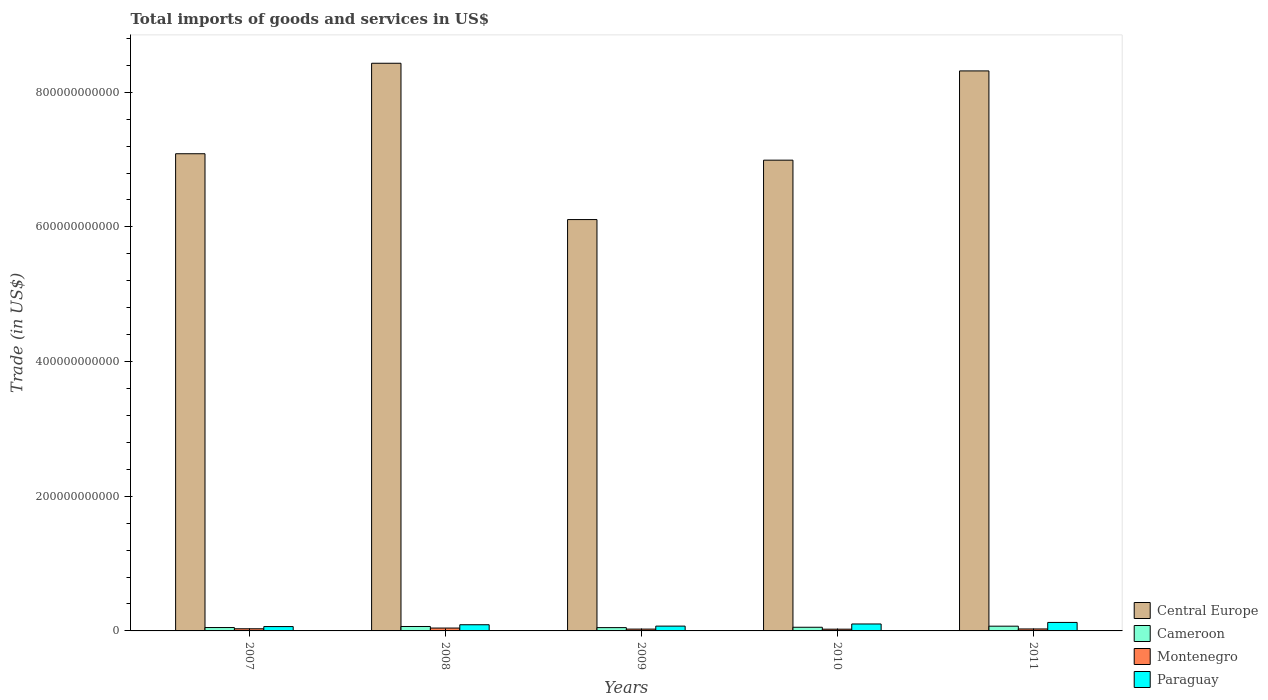How many different coloured bars are there?
Keep it short and to the point. 4. Are the number of bars on each tick of the X-axis equal?
Offer a terse response. Yes. How many bars are there on the 2nd tick from the left?
Give a very brief answer. 4. How many bars are there on the 2nd tick from the right?
Provide a short and direct response. 4. What is the label of the 5th group of bars from the left?
Keep it short and to the point. 2011. In how many cases, is the number of bars for a given year not equal to the number of legend labels?
Offer a terse response. 0. What is the total imports of goods and services in Central Europe in 2010?
Give a very brief answer. 6.99e+11. Across all years, what is the maximum total imports of goods and services in Central Europe?
Give a very brief answer. 8.43e+11. Across all years, what is the minimum total imports of goods and services in Cameroon?
Ensure brevity in your answer.  4.92e+09. What is the total total imports of goods and services in Cameroon in the graph?
Your response must be concise. 2.90e+1. What is the difference between the total imports of goods and services in Paraguay in 2007 and that in 2010?
Your answer should be compact. -3.85e+09. What is the difference between the total imports of goods and services in Cameroon in 2011 and the total imports of goods and services in Montenegro in 2008?
Provide a short and direct response. 2.79e+09. What is the average total imports of goods and services in Paraguay per year?
Offer a terse response. 9.14e+09. In the year 2008, what is the difference between the total imports of goods and services in Cameroon and total imports of goods and services in Central Europe?
Ensure brevity in your answer.  -8.36e+11. In how many years, is the total imports of goods and services in Montenegro greater than 840000000000 US$?
Make the answer very short. 0. What is the ratio of the total imports of goods and services in Paraguay in 2007 to that in 2009?
Your answer should be compact. 0.91. Is the difference between the total imports of goods and services in Cameroon in 2008 and 2009 greater than the difference between the total imports of goods and services in Central Europe in 2008 and 2009?
Keep it short and to the point. No. What is the difference between the highest and the second highest total imports of goods and services in Cameroon?
Provide a short and direct response. 4.59e+08. What is the difference between the highest and the lowest total imports of goods and services in Cameroon?
Offer a very short reply. 2.12e+09. What does the 2nd bar from the left in 2009 represents?
Provide a succinct answer. Cameroon. What does the 3rd bar from the right in 2007 represents?
Offer a very short reply. Cameroon. Are all the bars in the graph horizontal?
Your response must be concise. No. What is the difference between two consecutive major ticks on the Y-axis?
Offer a terse response. 2.00e+11. Does the graph contain grids?
Provide a succinct answer. No. Where does the legend appear in the graph?
Offer a very short reply. Bottom right. What is the title of the graph?
Provide a succinct answer. Total imports of goods and services in US$. Does "Samoa" appear as one of the legend labels in the graph?
Your answer should be compact. No. What is the label or title of the X-axis?
Give a very brief answer. Years. What is the label or title of the Y-axis?
Give a very brief answer. Trade (in US$). What is the Trade (in US$) of Central Europe in 2007?
Your response must be concise. 7.09e+11. What is the Trade (in US$) of Cameroon in 2007?
Offer a terse response. 5.03e+09. What is the Trade (in US$) of Montenegro in 2007?
Ensure brevity in your answer.  3.18e+09. What is the Trade (in US$) of Paraguay in 2007?
Ensure brevity in your answer.  6.46e+09. What is the Trade (in US$) of Central Europe in 2008?
Provide a succinct answer. 8.43e+11. What is the Trade (in US$) in Cameroon in 2008?
Your response must be concise. 6.58e+09. What is the Trade (in US$) in Montenegro in 2008?
Your answer should be very brief. 4.25e+09. What is the Trade (in US$) in Paraguay in 2008?
Make the answer very short. 9.17e+09. What is the Trade (in US$) in Central Europe in 2009?
Make the answer very short. 6.11e+11. What is the Trade (in US$) of Cameroon in 2009?
Offer a very short reply. 4.92e+09. What is the Trade (in US$) of Montenegro in 2009?
Offer a terse response. 2.71e+09. What is the Trade (in US$) of Paraguay in 2009?
Make the answer very short. 7.13e+09. What is the Trade (in US$) in Central Europe in 2010?
Keep it short and to the point. 6.99e+11. What is the Trade (in US$) in Cameroon in 2010?
Offer a terse response. 5.44e+09. What is the Trade (in US$) of Montenegro in 2010?
Provide a short and direct response. 2.60e+09. What is the Trade (in US$) of Paraguay in 2010?
Your response must be concise. 1.03e+1. What is the Trade (in US$) in Central Europe in 2011?
Your answer should be compact. 8.32e+11. What is the Trade (in US$) of Cameroon in 2011?
Offer a terse response. 7.04e+09. What is the Trade (in US$) in Montenegro in 2011?
Offer a very short reply. 2.92e+09. What is the Trade (in US$) in Paraguay in 2011?
Your answer should be compact. 1.26e+1. Across all years, what is the maximum Trade (in US$) of Central Europe?
Provide a succinct answer. 8.43e+11. Across all years, what is the maximum Trade (in US$) of Cameroon?
Offer a terse response. 7.04e+09. Across all years, what is the maximum Trade (in US$) in Montenegro?
Provide a short and direct response. 4.25e+09. Across all years, what is the maximum Trade (in US$) in Paraguay?
Your answer should be very brief. 1.26e+1. Across all years, what is the minimum Trade (in US$) in Central Europe?
Your answer should be very brief. 6.11e+11. Across all years, what is the minimum Trade (in US$) in Cameroon?
Give a very brief answer. 4.92e+09. Across all years, what is the minimum Trade (in US$) of Montenegro?
Your answer should be very brief. 2.60e+09. Across all years, what is the minimum Trade (in US$) in Paraguay?
Offer a terse response. 6.46e+09. What is the total Trade (in US$) in Central Europe in the graph?
Ensure brevity in your answer.  3.69e+12. What is the total Trade (in US$) in Cameroon in the graph?
Give a very brief answer. 2.90e+1. What is the total Trade (in US$) of Montenegro in the graph?
Your answer should be compact. 1.57e+1. What is the total Trade (in US$) of Paraguay in the graph?
Your response must be concise. 4.57e+1. What is the difference between the Trade (in US$) of Central Europe in 2007 and that in 2008?
Ensure brevity in your answer.  -1.34e+11. What is the difference between the Trade (in US$) in Cameroon in 2007 and that in 2008?
Give a very brief answer. -1.55e+09. What is the difference between the Trade (in US$) in Montenegro in 2007 and that in 2008?
Provide a succinct answer. -1.07e+09. What is the difference between the Trade (in US$) in Paraguay in 2007 and that in 2008?
Your response must be concise. -2.70e+09. What is the difference between the Trade (in US$) in Central Europe in 2007 and that in 2009?
Your answer should be very brief. 9.78e+1. What is the difference between the Trade (in US$) of Cameroon in 2007 and that in 2009?
Keep it short and to the point. 1.11e+08. What is the difference between the Trade (in US$) in Montenegro in 2007 and that in 2009?
Provide a short and direct response. 4.72e+08. What is the difference between the Trade (in US$) of Paraguay in 2007 and that in 2009?
Offer a terse response. -6.68e+08. What is the difference between the Trade (in US$) of Central Europe in 2007 and that in 2010?
Make the answer very short. 9.53e+09. What is the difference between the Trade (in US$) in Cameroon in 2007 and that in 2010?
Give a very brief answer. -4.09e+08. What is the difference between the Trade (in US$) in Montenegro in 2007 and that in 2010?
Offer a terse response. 5.84e+08. What is the difference between the Trade (in US$) of Paraguay in 2007 and that in 2010?
Your answer should be compact. -3.85e+09. What is the difference between the Trade (in US$) in Central Europe in 2007 and that in 2011?
Offer a terse response. -1.23e+11. What is the difference between the Trade (in US$) in Cameroon in 2007 and that in 2011?
Provide a short and direct response. -2.01e+09. What is the difference between the Trade (in US$) in Montenegro in 2007 and that in 2011?
Offer a very short reply. 2.62e+08. What is the difference between the Trade (in US$) of Paraguay in 2007 and that in 2011?
Offer a terse response. -6.15e+09. What is the difference between the Trade (in US$) of Central Europe in 2008 and that in 2009?
Give a very brief answer. 2.32e+11. What is the difference between the Trade (in US$) of Cameroon in 2008 and that in 2009?
Your answer should be very brief. 1.66e+09. What is the difference between the Trade (in US$) of Montenegro in 2008 and that in 2009?
Your answer should be very brief. 1.54e+09. What is the difference between the Trade (in US$) of Paraguay in 2008 and that in 2009?
Your response must be concise. 2.04e+09. What is the difference between the Trade (in US$) of Central Europe in 2008 and that in 2010?
Give a very brief answer. 1.44e+11. What is the difference between the Trade (in US$) in Cameroon in 2008 and that in 2010?
Your answer should be compact. 1.14e+09. What is the difference between the Trade (in US$) in Montenegro in 2008 and that in 2010?
Give a very brief answer. 1.65e+09. What is the difference between the Trade (in US$) in Paraguay in 2008 and that in 2010?
Your answer should be very brief. -1.15e+09. What is the difference between the Trade (in US$) of Central Europe in 2008 and that in 2011?
Give a very brief answer. 1.14e+1. What is the difference between the Trade (in US$) in Cameroon in 2008 and that in 2011?
Ensure brevity in your answer.  -4.59e+08. What is the difference between the Trade (in US$) of Montenegro in 2008 and that in 2011?
Your answer should be very brief. 1.33e+09. What is the difference between the Trade (in US$) in Paraguay in 2008 and that in 2011?
Offer a very short reply. -3.44e+09. What is the difference between the Trade (in US$) in Central Europe in 2009 and that in 2010?
Make the answer very short. -8.82e+1. What is the difference between the Trade (in US$) in Cameroon in 2009 and that in 2010?
Your answer should be very brief. -5.20e+08. What is the difference between the Trade (in US$) in Montenegro in 2009 and that in 2010?
Ensure brevity in your answer.  1.13e+08. What is the difference between the Trade (in US$) of Paraguay in 2009 and that in 2010?
Provide a short and direct response. -3.18e+09. What is the difference between the Trade (in US$) in Central Europe in 2009 and that in 2011?
Your answer should be compact. -2.21e+11. What is the difference between the Trade (in US$) in Cameroon in 2009 and that in 2011?
Provide a succinct answer. -2.12e+09. What is the difference between the Trade (in US$) in Montenegro in 2009 and that in 2011?
Your answer should be very brief. -2.09e+08. What is the difference between the Trade (in US$) of Paraguay in 2009 and that in 2011?
Provide a succinct answer. -5.48e+09. What is the difference between the Trade (in US$) of Central Europe in 2010 and that in 2011?
Make the answer very short. -1.33e+11. What is the difference between the Trade (in US$) of Cameroon in 2010 and that in 2011?
Provide a short and direct response. -1.60e+09. What is the difference between the Trade (in US$) in Montenegro in 2010 and that in 2011?
Your answer should be compact. -3.22e+08. What is the difference between the Trade (in US$) in Paraguay in 2010 and that in 2011?
Your answer should be compact. -2.29e+09. What is the difference between the Trade (in US$) of Central Europe in 2007 and the Trade (in US$) of Cameroon in 2008?
Your answer should be very brief. 7.02e+11. What is the difference between the Trade (in US$) of Central Europe in 2007 and the Trade (in US$) of Montenegro in 2008?
Your response must be concise. 7.04e+11. What is the difference between the Trade (in US$) of Central Europe in 2007 and the Trade (in US$) of Paraguay in 2008?
Offer a terse response. 6.99e+11. What is the difference between the Trade (in US$) in Cameroon in 2007 and the Trade (in US$) in Montenegro in 2008?
Your answer should be very brief. 7.79e+08. What is the difference between the Trade (in US$) in Cameroon in 2007 and the Trade (in US$) in Paraguay in 2008?
Provide a succinct answer. -4.14e+09. What is the difference between the Trade (in US$) in Montenegro in 2007 and the Trade (in US$) in Paraguay in 2008?
Make the answer very short. -5.99e+09. What is the difference between the Trade (in US$) of Central Europe in 2007 and the Trade (in US$) of Cameroon in 2009?
Provide a succinct answer. 7.04e+11. What is the difference between the Trade (in US$) in Central Europe in 2007 and the Trade (in US$) in Montenegro in 2009?
Provide a succinct answer. 7.06e+11. What is the difference between the Trade (in US$) of Central Europe in 2007 and the Trade (in US$) of Paraguay in 2009?
Your response must be concise. 7.01e+11. What is the difference between the Trade (in US$) of Cameroon in 2007 and the Trade (in US$) of Montenegro in 2009?
Your response must be concise. 2.32e+09. What is the difference between the Trade (in US$) in Cameroon in 2007 and the Trade (in US$) in Paraguay in 2009?
Your answer should be compact. -2.10e+09. What is the difference between the Trade (in US$) in Montenegro in 2007 and the Trade (in US$) in Paraguay in 2009?
Your response must be concise. -3.95e+09. What is the difference between the Trade (in US$) of Central Europe in 2007 and the Trade (in US$) of Cameroon in 2010?
Offer a terse response. 7.03e+11. What is the difference between the Trade (in US$) of Central Europe in 2007 and the Trade (in US$) of Montenegro in 2010?
Provide a short and direct response. 7.06e+11. What is the difference between the Trade (in US$) of Central Europe in 2007 and the Trade (in US$) of Paraguay in 2010?
Your answer should be very brief. 6.98e+11. What is the difference between the Trade (in US$) of Cameroon in 2007 and the Trade (in US$) of Montenegro in 2010?
Provide a short and direct response. 2.43e+09. What is the difference between the Trade (in US$) in Cameroon in 2007 and the Trade (in US$) in Paraguay in 2010?
Your response must be concise. -5.29e+09. What is the difference between the Trade (in US$) in Montenegro in 2007 and the Trade (in US$) in Paraguay in 2010?
Make the answer very short. -7.13e+09. What is the difference between the Trade (in US$) in Central Europe in 2007 and the Trade (in US$) in Cameroon in 2011?
Provide a succinct answer. 7.02e+11. What is the difference between the Trade (in US$) in Central Europe in 2007 and the Trade (in US$) in Montenegro in 2011?
Keep it short and to the point. 7.06e+11. What is the difference between the Trade (in US$) in Central Europe in 2007 and the Trade (in US$) in Paraguay in 2011?
Make the answer very short. 6.96e+11. What is the difference between the Trade (in US$) in Cameroon in 2007 and the Trade (in US$) in Montenegro in 2011?
Provide a succinct answer. 2.11e+09. What is the difference between the Trade (in US$) in Cameroon in 2007 and the Trade (in US$) in Paraguay in 2011?
Ensure brevity in your answer.  -7.58e+09. What is the difference between the Trade (in US$) of Montenegro in 2007 and the Trade (in US$) of Paraguay in 2011?
Give a very brief answer. -9.43e+09. What is the difference between the Trade (in US$) of Central Europe in 2008 and the Trade (in US$) of Cameroon in 2009?
Your answer should be compact. 8.38e+11. What is the difference between the Trade (in US$) of Central Europe in 2008 and the Trade (in US$) of Montenegro in 2009?
Give a very brief answer. 8.40e+11. What is the difference between the Trade (in US$) in Central Europe in 2008 and the Trade (in US$) in Paraguay in 2009?
Provide a short and direct response. 8.36e+11. What is the difference between the Trade (in US$) in Cameroon in 2008 and the Trade (in US$) in Montenegro in 2009?
Your answer should be very brief. 3.87e+09. What is the difference between the Trade (in US$) in Cameroon in 2008 and the Trade (in US$) in Paraguay in 2009?
Provide a short and direct response. -5.50e+08. What is the difference between the Trade (in US$) in Montenegro in 2008 and the Trade (in US$) in Paraguay in 2009?
Provide a succinct answer. -2.88e+09. What is the difference between the Trade (in US$) of Central Europe in 2008 and the Trade (in US$) of Cameroon in 2010?
Make the answer very short. 8.38e+11. What is the difference between the Trade (in US$) in Central Europe in 2008 and the Trade (in US$) in Montenegro in 2010?
Make the answer very short. 8.40e+11. What is the difference between the Trade (in US$) in Central Europe in 2008 and the Trade (in US$) in Paraguay in 2010?
Provide a succinct answer. 8.33e+11. What is the difference between the Trade (in US$) in Cameroon in 2008 and the Trade (in US$) in Montenegro in 2010?
Offer a terse response. 3.98e+09. What is the difference between the Trade (in US$) in Cameroon in 2008 and the Trade (in US$) in Paraguay in 2010?
Offer a terse response. -3.73e+09. What is the difference between the Trade (in US$) of Montenegro in 2008 and the Trade (in US$) of Paraguay in 2010?
Offer a very short reply. -6.06e+09. What is the difference between the Trade (in US$) of Central Europe in 2008 and the Trade (in US$) of Cameroon in 2011?
Offer a very short reply. 8.36e+11. What is the difference between the Trade (in US$) in Central Europe in 2008 and the Trade (in US$) in Montenegro in 2011?
Provide a succinct answer. 8.40e+11. What is the difference between the Trade (in US$) in Central Europe in 2008 and the Trade (in US$) in Paraguay in 2011?
Keep it short and to the point. 8.30e+11. What is the difference between the Trade (in US$) in Cameroon in 2008 and the Trade (in US$) in Montenegro in 2011?
Keep it short and to the point. 3.66e+09. What is the difference between the Trade (in US$) in Cameroon in 2008 and the Trade (in US$) in Paraguay in 2011?
Ensure brevity in your answer.  -6.03e+09. What is the difference between the Trade (in US$) of Montenegro in 2008 and the Trade (in US$) of Paraguay in 2011?
Give a very brief answer. -8.36e+09. What is the difference between the Trade (in US$) of Central Europe in 2009 and the Trade (in US$) of Cameroon in 2010?
Make the answer very short. 6.05e+11. What is the difference between the Trade (in US$) in Central Europe in 2009 and the Trade (in US$) in Montenegro in 2010?
Your response must be concise. 6.08e+11. What is the difference between the Trade (in US$) in Central Europe in 2009 and the Trade (in US$) in Paraguay in 2010?
Keep it short and to the point. 6.01e+11. What is the difference between the Trade (in US$) in Cameroon in 2009 and the Trade (in US$) in Montenegro in 2010?
Give a very brief answer. 2.32e+09. What is the difference between the Trade (in US$) of Cameroon in 2009 and the Trade (in US$) of Paraguay in 2010?
Provide a short and direct response. -5.40e+09. What is the difference between the Trade (in US$) in Montenegro in 2009 and the Trade (in US$) in Paraguay in 2010?
Your answer should be very brief. -7.60e+09. What is the difference between the Trade (in US$) in Central Europe in 2009 and the Trade (in US$) in Cameroon in 2011?
Ensure brevity in your answer.  6.04e+11. What is the difference between the Trade (in US$) of Central Europe in 2009 and the Trade (in US$) of Montenegro in 2011?
Offer a terse response. 6.08e+11. What is the difference between the Trade (in US$) in Central Europe in 2009 and the Trade (in US$) in Paraguay in 2011?
Your response must be concise. 5.98e+11. What is the difference between the Trade (in US$) of Cameroon in 2009 and the Trade (in US$) of Montenegro in 2011?
Give a very brief answer. 2.00e+09. What is the difference between the Trade (in US$) of Cameroon in 2009 and the Trade (in US$) of Paraguay in 2011?
Ensure brevity in your answer.  -7.69e+09. What is the difference between the Trade (in US$) of Montenegro in 2009 and the Trade (in US$) of Paraguay in 2011?
Make the answer very short. -9.90e+09. What is the difference between the Trade (in US$) of Central Europe in 2010 and the Trade (in US$) of Cameroon in 2011?
Your answer should be very brief. 6.92e+11. What is the difference between the Trade (in US$) of Central Europe in 2010 and the Trade (in US$) of Montenegro in 2011?
Offer a very short reply. 6.96e+11. What is the difference between the Trade (in US$) of Central Europe in 2010 and the Trade (in US$) of Paraguay in 2011?
Offer a terse response. 6.86e+11. What is the difference between the Trade (in US$) of Cameroon in 2010 and the Trade (in US$) of Montenegro in 2011?
Provide a short and direct response. 2.52e+09. What is the difference between the Trade (in US$) of Cameroon in 2010 and the Trade (in US$) of Paraguay in 2011?
Your response must be concise. -7.17e+09. What is the difference between the Trade (in US$) in Montenegro in 2010 and the Trade (in US$) in Paraguay in 2011?
Your answer should be very brief. -1.00e+1. What is the average Trade (in US$) in Central Europe per year?
Give a very brief answer. 7.39e+11. What is the average Trade (in US$) of Cameroon per year?
Offer a terse response. 5.80e+09. What is the average Trade (in US$) in Montenegro per year?
Give a very brief answer. 3.13e+09. What is the average Trade (in US$) in Paraguay per year?
Your response must be concise. 9.14e+09. In the year 2007, what is the difference between the Trade (in US$) in Central Europe and Trade (in US$) in Cameroon?
Make the answer very short. 7.04e+11. In the year 2007, what is the difference between the Trade (in US$) in Central Europe and Trade (in US$) in Montenegro?
Keep it short and to the point. 7.05e+11. In the year 2007, what is the difference between the Trade (in US$) in Central Europe and Trade (in US$) in Paraguay?
Give a very brief answer. 7.02e+11. In the year 2007, what is the difference between the Trade (in US$) in Cameroon and Trade (in US$) in Montenegro?
Make the answer very short. 1.85e+09. In the year 2007, what is the difference between the Trade (in US$) of Cameroon and Trade (in US$) of Paraguay?
Offer a terse response. -1.43e+09. In the year 2007, what is the difference between the Trade (in US$) of Montenegro and Trade (in US$) of Paraguay?
Make the answer very short. -3.28e+09. In the year 2008, what is the difference between the Trade (in US$) of Central Europe and Trade (in US$) of Cameroon?
Make the answer very short. 8.36e+11. In the year 2008, what is the difference between the Trade (in US$) of Central Europe and Trade (in US$) of Montenegro?
Give a very brief answer. 8.39e+11. In the year 2008, what is the difference between the Trade (in US$) of Central Europe and Trade (in US$) of Paraguay?
Your answer should be compact. 8.34e+11. In the year 2008, what is the difference between the Trade (in US$) of Cameroon and Trade (in US$) of Montenegro?
Your answer should be very brief. 2.33e+09. In the year 2008, what is the difference between the Trade (in US$) of Cameroon and Trade (in US$) of Paraguay?
Make the answer very short. -2.59e+09. In the year 2008, what is the difference between the Trade (in US$) of Montenegro and Trade (in US$) of Paraguay?
Provide a succinct answer. -4.92e+09. In the year 2009, what is the difference between the Trade (in US$) in Central Europe and Trade (in US$) in Cameroon?
Your answer should be compact. 6.06e+11. In the year 2009, what is the difference between the Trade (in US$) of Central Europe and Trade (in US$) of Montenegro?
Keep it short and to the point. 6.08e+11. In the year 2009, what is the difference between the Trade (in US$) in Central Europe and Trade (in US$) in Paraguay?
Make the answer very short. 6.04e+11. In the year 2009, what is the difference between the Trade (in US$) in Cameroon and Trade (in US$) in Montenegro?
Your answer should be compact. 2.21e+09. In the year 2009, what is the difference between the Trade (in US$) of Cameroon and Trade (in US$) of Paraguay?
Keep it short and to the point. -2.21e+09. In the year 2009, what is the difference between the Trade (in US$) of Montenegro and Trade (in US$) of Paraguay?
Offer a terse response. -4.42e+09. In the year 2010, what is the difference between the Trade (in US$) of Central Europe and Trade (in US$) of Cameroon?
Your response must be concise. 6.94e+11. In the year 2010, what is the difference between the Trade (in US$) of Central Europe and Trade (in US$) of Montenegro?
Your response must be concise. 6.96e+11. In the year 2010, what is the difference between the Trade (in US$) in Central Europe and Trade (in US$) in Paraguay?
Provide a succinct answer. 6.89e+11. In the year 2010, what is the difference between the Trade (in US$) in Cameroon and Trade (in US$) in Montenegro?
Keep it short and to the point. 2.84e+09. In the year 2010, what is the difference between the Trade (in US$) of Cameroon and Trade (in US$) of Paraguay?
Your response must be concise. -4.88e+09. In the year 2010, what is the difference between the Trade (in US$) of Montenegro and Trade (in US$) of Paraguay?
Your answer should be compact. -7.72e+09. In the year 2011, what is the difference between the Trade (in US$) in Central Europe and Trade (in US$) in Cameroon?
Offer a very short reply. 8.25e+11. In the year 2011, what is the difference between the Trade (in US$) in Central Europe and Trade (in US$) in Montenegro?
Ensure brevity in your answer.  8.29e+11. In the year 2011, what is the difference between the Trade (in US$) of Central Europe and Trade (in US$) of Paraguay?
Provide a short and direct response. 8.19e+11. In the year 2011, what is the difference between the Trade (in US$) in Cameroon and Trade (in US$) in Montenegro?
Keep it short and to the point. 4.12e+09. In the year 2011, what is the difference between the Trade (in US$) in Cameroon and Trade (in US$) in Paraguay?
Offer a terse response. -5.57e+09. In the year 2011, what is the difference between the Trade (in US$) in Montenegro and Trade (in US$) in Paraguay?
Your response must be concise. -9.69e+09. What is the ratio of the Trade (in US$) of Central Europe in 2007 to that in 2008?
Your answer should be compact. 0.84. What is the ratio of the Trade (in US$) of Cameroon in 2007 to that in 2008?
Your response must be concise. 0.76. What is the ratio of the Trade (in US$) in Montenegro in 2007 to that in 2008?
Make the answer very short. 0.75. What is the ratio of the Trade (in US$) of Paraguay in 2007 to that in 2008?
Your response must be concise. 0.7. What is the ratio of the Trade (in US$) of Central Europe in 2007 to that in 2009?
Your response must be concise. 1.16. What is the ratio of the Trade (in US$) of Cameroon in 2007 to that in 2009?
Ensure brevity in your answer.  1.02. What is the ratio of the Trade (in US$) in Montenegro in 2007 to that in 2009?
Provide a short and direct response. 1.17. What is the ratio of the Trade (in US$) in Paraguay in 2007 to that in 2009?
Your response must be concise. 0.91. What is the ratio of the Trade (in US$) in Central Europe in 2007 to that in 2010?
Offer a terse response. 1.01. What is the ratio of the Trade (in US$) of Cameroon in 2007 to that in 2010?
Provide a succinct answer. 0.92. What is the ratio of the Trade (in US$) in Montenegro in 2007 to that in 2010?
Keep it short and to the point. 1.22. What is the ratio of the Trade (in US$) of Paraguay in 2007 to that in 2010?
Your response must be concise. 0.63. What is the ratio of the Trade (in US$) of Central Europe in 2007 to that in 2011?
Offer a very short reply. 0.85. What is the ratio of the Trade (in US$) of Montenegro in 2007 to that in 2011?
Your answer should be compact. 1.09. What is the ratio of the Trade (in US$) of Paraguay in 2007 to that in 2011?
Keep it short and to the point. 0.51. What is the ratio of the Trade (in US$) in Central Europe in 2008 to that in 2009?
Your response must be concise. 1.38. What is the ratio of the Trade (in US$) of Cameroon in 2008 to that in 2009?
Offer a very short reply. 1.34. What is the ratio of the Trade (in US$) of Montenegro in 2008 to that in 2009?
Provide a succinct answer. 1.57. What is the ratio of the Trade (in US$) of Paraguay in 2008 to that in 2009?
Make the answer very short. 1.29. What is the ratio of the Trade (in US$) of Central Europe in 2008 to that in 2010?
Ensure brevity in your answer.  1.21. What is the ratio of the Trade (in US$) in Cameroon in 2008 to that in 2010?
Your answer should be compact. 1.21. What is the ratio of the Trade (in US$) of Montenegro in 2008 to that in 2010?
Your answer should be compact. 1.64. What is the ratio of the Trade (in US$) in Paraguay in 2008 to that in 2010?
Ensure brevity in your answer.  0.89. What is the ratio of the Trade (in US$) of Central Europe in 2008 to that in 2011?
Your answer should be very brief. 1.01. What is the ratio of the Trade (in US$) of Cameroon in 2008 to that in 2011?
Ensure brevity in your answer.  0.93. What is the ratio of the Trade (in US$) in Montenegro in 2008 to that in 2011?
Make the answer very short. 1.46. What is the ratio of the Trade (in US$) of Paraguay in 2008 to that in 2011?
Make the answer very short. 0.73. What is the ratio of the Trade (in US$) of Central Europe in 2009 to that in 2010?
Make the answer very short. 0.87. What is the ratio of the Trade (in US$) of Cameroon in 2009 to that in 2010?
Offer a terse response. 0.9. What is the ratio of the Trade (in US$) of Montenegro in 2009 to that in 2010?
Provide a succinct answer. 1.04. What is the ratio of the Trade (in US$) of Paraguay in 2009 to that in 2010?
Keep it short and to the point. 0.69. What is the ratio of the Trade (in US$) of Central Europe in 2009 to that in 2011?
Provide a succinct answer. 0.73. What is the ratio of the Trade (in US$) in Cameroon in 2009 to that in 2011?
Provide a short and direct response. 0.7. What is the ratio of the Trade (in US$) of Montenegro in 2009 to that in 2011?
Ensure brevity in your answer.  0.93. What is the ratio of the Trade (in US$) in Paraguay in 2009 to that in 2011?
Give a very brief answer. 0.57. What is the ratio of the Trade (in US$) of Central Europe in 2010 to that in 2011?
Offer a very short reply. 0.84. What is the ratio of the Trade (in US$) in Cameroon in 2010 to that in 2011?
Keep it short and to the point. 0.77. What is the ratio of the Trade (in US$) of Montenegro in 2010 to that in 2011?
Your answer should be very brief. 0.89. What is the ratio of the Trade (in US$) in Paraguay in 2010 to that in 2011?
Offer a very short reply. 0.82. What is the difference between the highest and the second highest Trade (in US$) of Central Europe?
Give a very brief answer. 1.14e+1. What is the difference between the highest and the second highest Trade (in US$) of Cameroon?
Ensure brevity in your answer.  4.59e+08. What is the difference between the highest and the second highest Trade (in US$) of Montenegro?
Provide a short and direct response. 1.07e+09. What is the difference between the highest and the second highest Trade (in US$) in Paraguay?
Make the answer very short. 2.29e+09. What is the difference between the highest and the lowest Trade (in US$) in Central Europe?
Ensure brevity in your answer.  2.32e+11. What is the difference between the highest and the lowest Trade (in US$) of Cameroon?
Offer a very short reply. 2.12e+09. What is the difference between the highest and the lowest Trade (in US$) of Montenegro?
Ensure brevity in your answer.  1.65e+09. What is the difference between the highest and the lowest Trade (in US$) of Paraguay?
Offer a very short reply. 6.15e+09. 